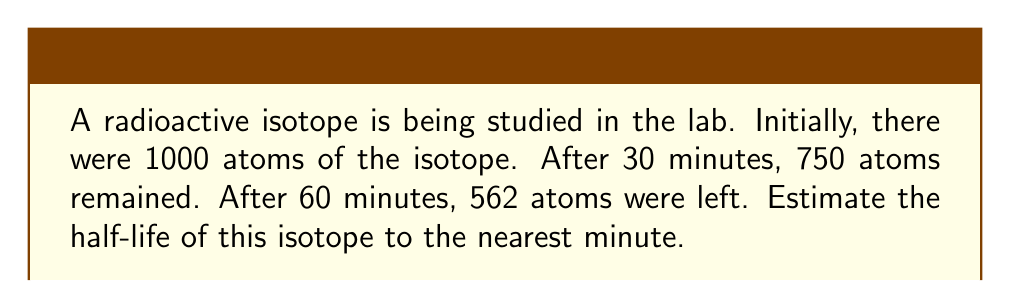Provide a solution to this math problem. To solve this problem, we'll use the exponential decay formula and the definition of half-life. Let's approach this step-by-step:

1) The exponential decay formula is:
   $$N(t) = N_0 \cdot e^{-\lambda t}$$
   where $N(t)$ is the number of atoms at time $t$, $N_0$ is the initial number of atoms, and $\lambda$ is the decay constant.

2) The half-life $T_{1/2}$ is related to $\lambda$ by:
   $$T_{1/2} = \frac{\ln(2)}{\lambda}$$

3) We can find $\lambda$ using the data points given. Let's use the initial and 60-minute measurements:
   $$562 = 1000 \cdot e^{-60\lambda}$$

4) Solving for $\lambda$:
   $$\frac{562}{1000} = e^{-60\lambda}$$
   $$\ln(\frac{562}{1000}) = -60\lambda$$
   $$\lambda = -\frac{\ln(0.562)}{60} \approx 0.00958 \text{ min}^{-1}$$

5) Now we can calculate the half-life:
   $$T_{1/2} = \frac{\ln(2)}{0.00958} \approx 72.3 \text{ minutes}$$

6) Rounding to the nearest minute gives us 72 minutes.

7) We can verify this result using the 30-minute measurement:
   $$N(30) = 1000 \cdot e^{-0.00958 \cdot 30} \approx 751$$
   This is very close to the given value of 750 atoms, confirming our calculation.
Answer: 72 minutes 